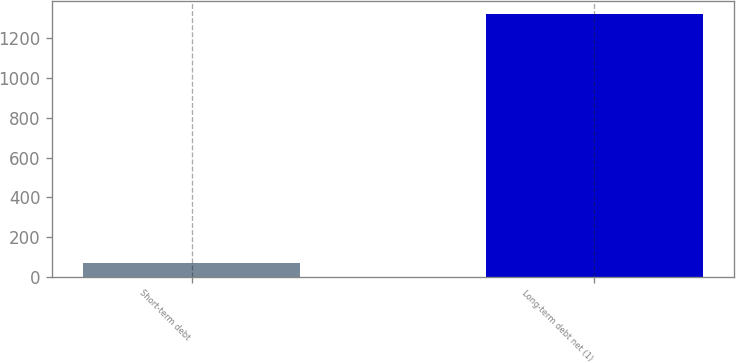<chart> <loc_0><loc_0><loc_500><loc_500><bar_chart><fcel>Short-term debt<fcel>Long-term debt net (1)<nl><fcel>70<fcel>1324<nl></chart> 